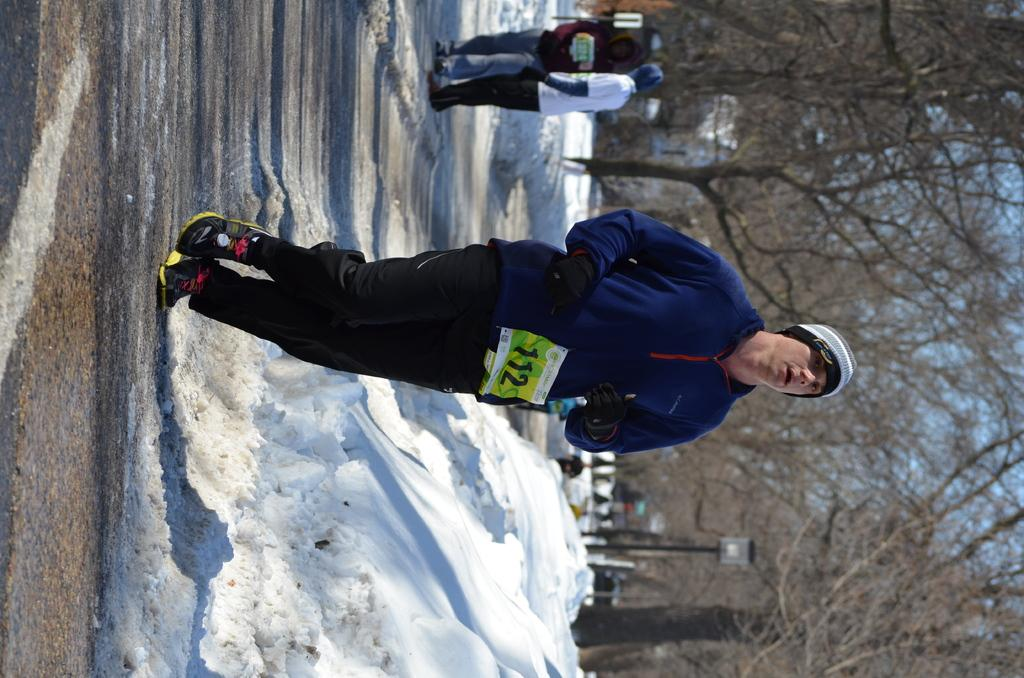What can be seen in the image? There is a person in the image. Can you describe the person's attire? The person is wearing a cap and gloves. Does the person have any identification in the image? Yes, the person has a chest number. What is the weather like in the image? There is snow on the ground. What can be seen in the background of the image? There are people and trees in the background. How far away is the lunch break location from the person in the image? There is no indication of a lunch break location or distance in the image. 